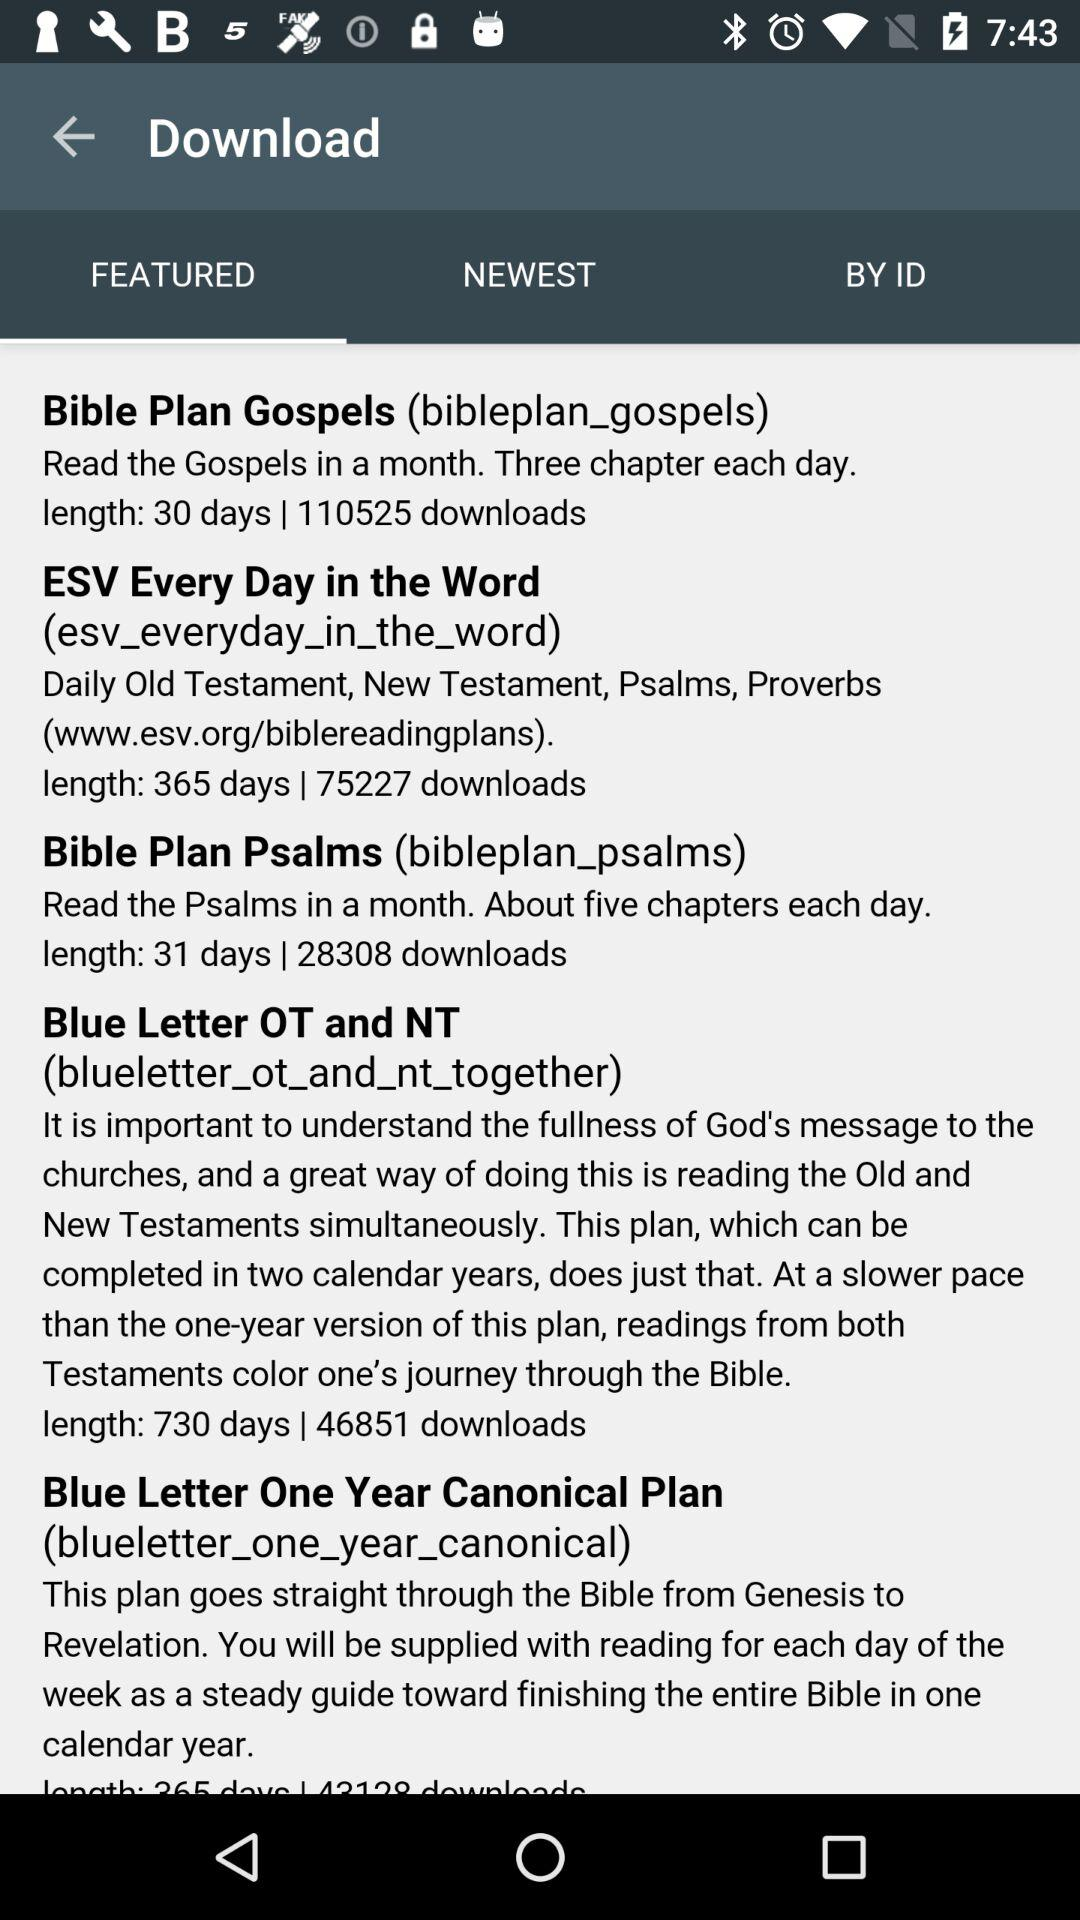Which is the selected tab in the "Download"? The selected tab in the "Download" is "FEATURED". 